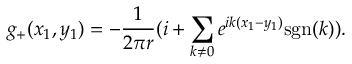<formula> <loc_0><loc_0><loc_500><loc_500>g _ { + } ( x _ { 1 } , y _ { 1 } ) = - \frac { 1 } { 2 \pi r } ( i + \sum _ { k \neq 0 } e ^ { i k ( x _ { 1 } - y _ { 1 } ) } s g n ( k ) ) .</formula> 